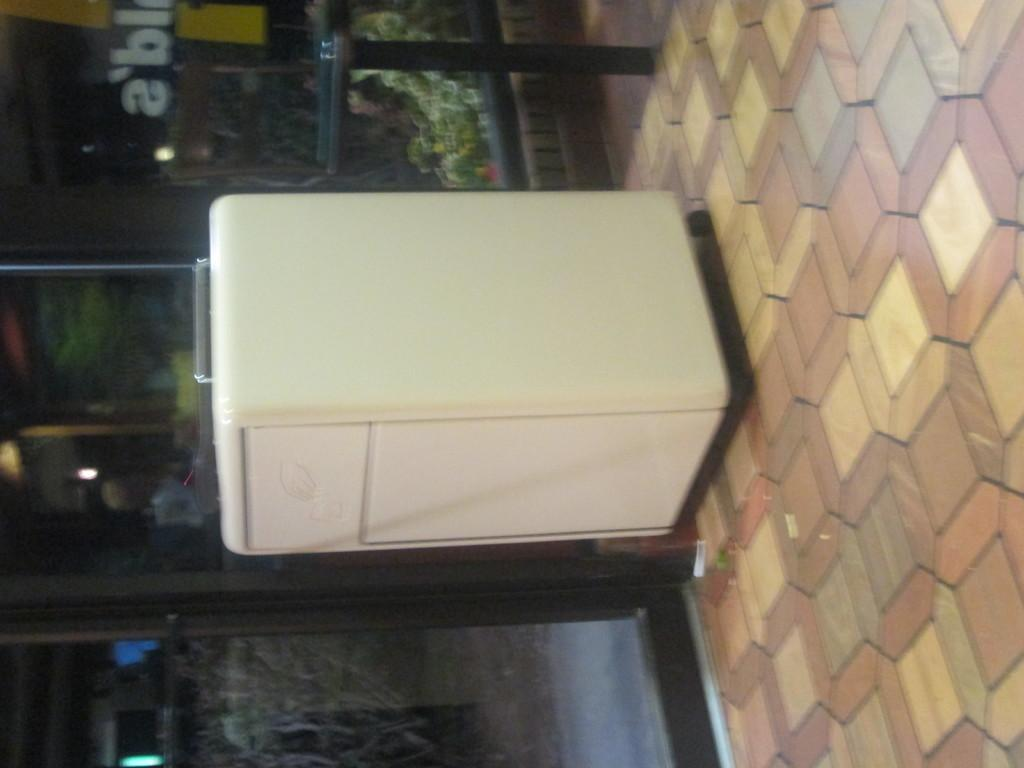What is the color of the object in the image? The object in the image is white. What type of furniture is on the floor in the image? There is a table on the floor in the image. Where is the poster located in the image? The poster is on a glass surface in the image. What can be seen through the glass in the image? Plants are visible through the glass in the image. What type of baseball polish is visible on the table in the image? There is no baseball or polish present in the image; it features a white object, a table, a poster on a glass surface, and plants visible through the glass. 